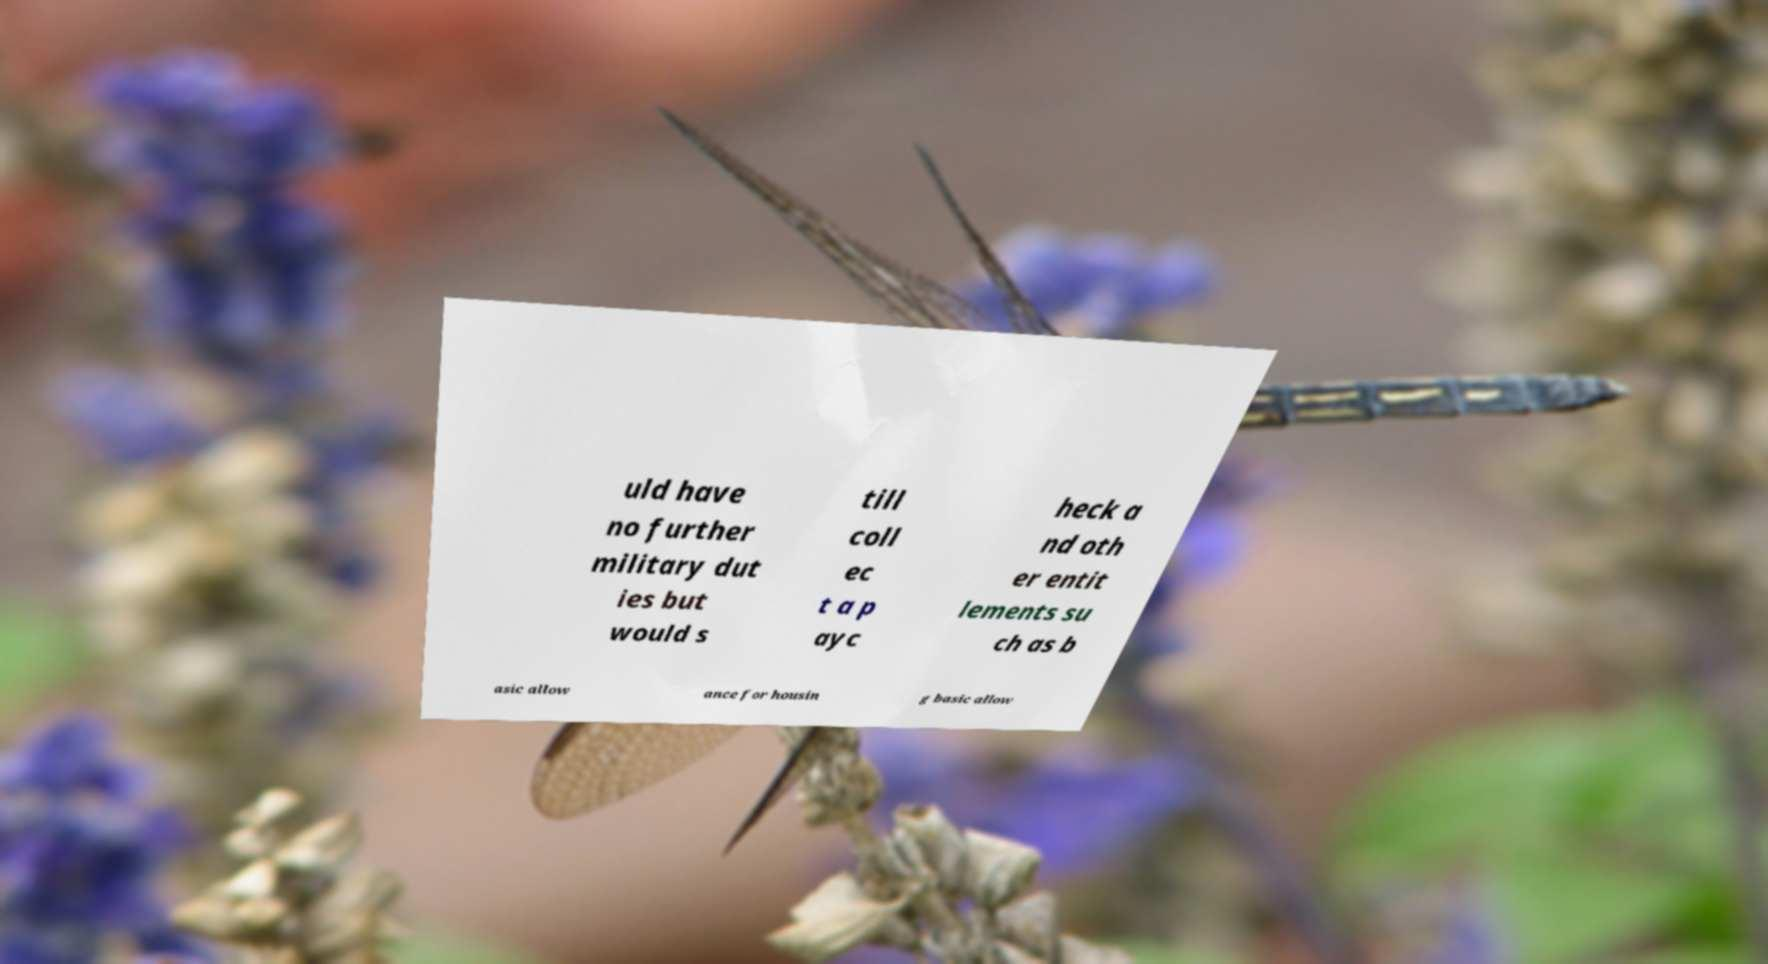Can you accurately transcribe the text from the provided image for me? uld have no further military dut ies but would s till coll ec t a p ayc heck a nd oth er entit lements su ch as b asic allow ance for housin g basic allow 